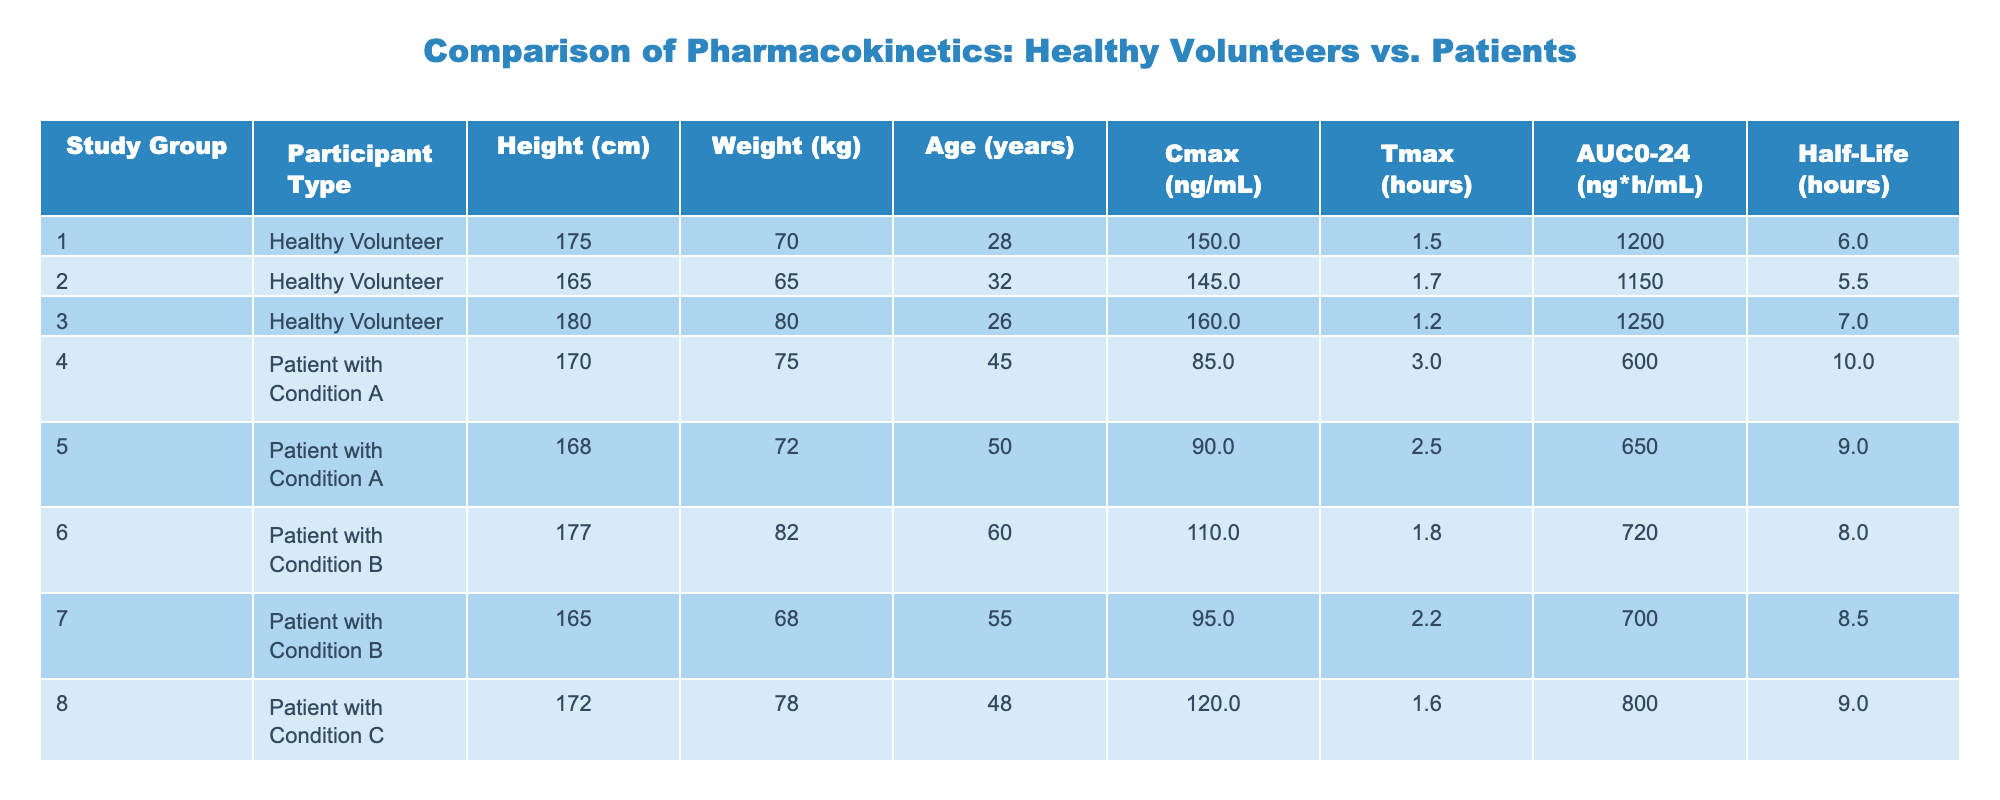What is the Cmax for the Patient with Condition A who is 50 years old? From the table, I find the row corresponding to Patient with Condition A and Age 50, which is Participant 5. The Cmax value for this participant is listed as 90 ng/mL.
Answer: 90 ng/mL What is the average age of the Healthy Volunteers? The ages of the Healthy Volunteers are 28, 32, and 26. To find the average, I sum these ages: 28 + 32 + 26 = 86. Then divide by the number of Healthy Volunteers (3): 86 / 3 = 28.67.
Answer: 28.67 years Did any participants have a Half-Life greater than 7 hours? By examining the Half-Life column, I see that the Healthy Volunteer data points (6, 5.5, and 7) are less than or equal to 7 hours; however, the Patients have values of 10, 9, 8, 8.5, and 9. The patient values exceed 7 hours, confirming that yes, there are participants with a Half-Life greater than 7 hours.
Answer: Yes Which group has the highest average AUC0-24? I must first calculate the AUC0-24 for each group. The Healthy Volunteers have AUC0-24 values of 1200, 1150, and 1250, which sum to 3600 and divided by 3 gives 1200. The Patients have AUC0-24 values of 600, 650, 720, 700, and 800, which sum to 3570 and divided by 5 gives 714. Since 1200 > 714, the Healthy Volunteers have the highest average AUC0-24.
Answer: Healthy Volunteers What is the Cmax for the Patient with Condition B who is 60 years old? I check the table for Patient with Condition B and find the corresponding age of 60, which is Participant 6. The Cmax value given is 110 ng/mL.
Answer: 110 ng/mL How many Healthy Volunteers have a Tmax of 1.5 hours or lower? Looking at the Tmax values for Healthy Volunteers, I find 1.5, 1.7, and 1.2 hours. Only the first and third values (1.5 and 1.2) meet the criteria, resulting in a total of 2 Healthy Volunteers.
Answer: 2 